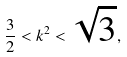Convert formula to latex. <formula><loc_0><loc_0><loc_500><loc_500>\frac { 3 } { 2 } < k ^ { 2 } < \sqrt { 3 } ,</formula> 